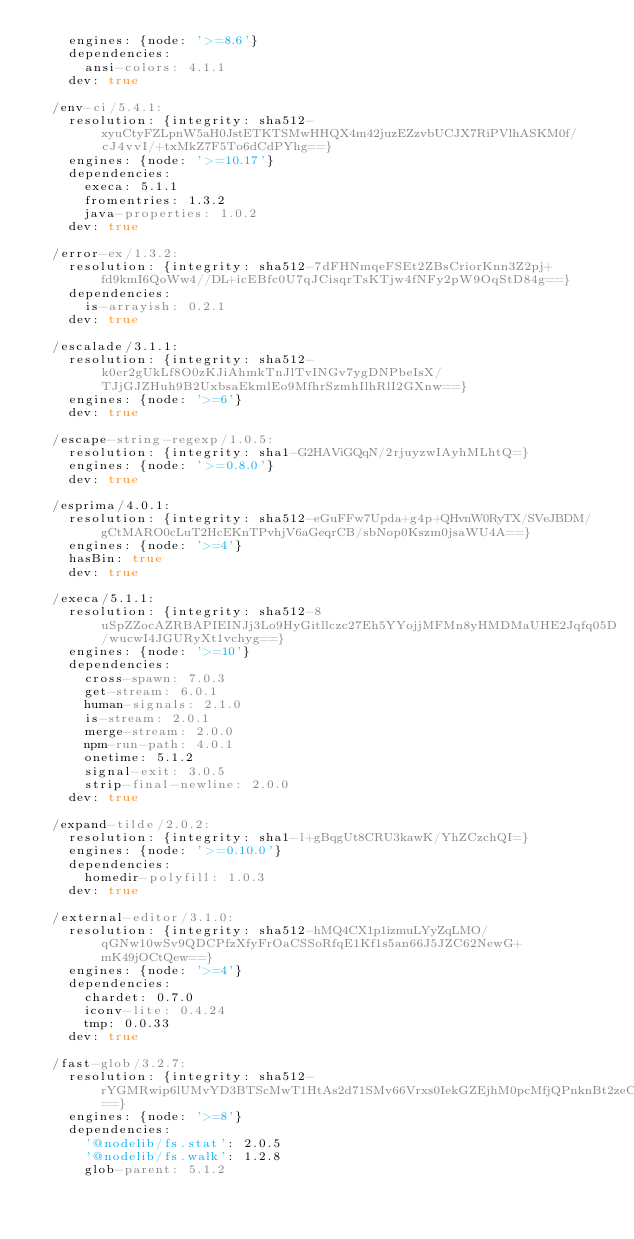Convert code to text. <code><loc_0><loc_0><loc_500><loc_500><_YAML_>    engines: {node: '>=8.6'}
    dependencies:
      ansi-colors: 4.1.1
    dev: true

  /env-ci/5.4.1:
    resolution: {integrity: sha512-xyuCtyFZLpnW5aH0JstETKTSMwHHQX4m42juzEZzvbUCJX7RiPVlhASKM0f/cJ4vvI/+txMkZ7F5To6dCdPYhg==}
    engines: {node: '>=10.17'}
    dependencies:
      execa: 5.1.1
      fromentries: 1.3.2
      java-properties: 1.0.2
    dev: true

  /error-ex/1.3.2:
    resolution: {integrity: sha512-7dFHNmqeFSEt2ZBsCriorKnn3Z2pj+fd9kmI6QoWw4//DL+icEBfc0U7qJCisqrTsKTjw4fNFy2pW9OqStD84g==}
    dependencies:
      is-arrayish: 0.2.1
    dev: true

  /escalade/3.1.1:
    resolution: {integrity: sha512-k0er2gUkLf8O0zKJiAhmkTnJlTvINGv7ygDNPbeIsX/TJjGJZHuh9B2UxbsaEkmlEo9MfhrSzmhIlhRlI2GXnw==}
    engines: {node: '>=6'}
    dev: true

  /escape-string-regexp/1.0.5:
    resolution: {integrity: sha1-G2HAViGQqN/2rjuyzwIAyhMLhtQ=}
    engines: {node: '>=0.8.0'}
    dev: true

  /esprima/4.0.1:
    resolution: {integrity: sha512-eGuFFw7Upda+g4p+QHvnW0RyTX/SVeJBDM/gCtMARO0cLuT2HcEKnTPvhjV6aGeqrCB/sbNop0Kszm0jsaWU4A==}
    engines: {node: '>=4'}
    hasBin: true
    dev: true

  /execa/5.1.1:
    resolution: {integrity: sha512-8uSpZZocAZRBAPIEINJj3Lo9HyGitllczc27Eh5YYojjMFMn8yHMDMaUHE2Jqfq05D/wucwI4JGURyXt1vchyg==}
    engines: {node: '>=10'}
    dependencies:
      cross-spawn: 7.0.3
      get-stream: 6.0.1
      human-signals: 2.1.0
      is-stream: 2.0.1
      merge-stream: 2.0.0
      npm-run-path: 4.0.1
      onetime: 5.1.2
      signal-exit: 3.0.5
      strip-final-newline: 2.0.0
    dev: true

  /expand-tilde/2.0.2:
    resolution: {integrity: sha1-l+gBqgUt8CRU3kawK/YhZCzchQI=}
    engines: {node: '>=0.10.0'}
    dependencies:
      homedir-polyfill: 1.0.3
    dev: true

  /external-editor/3.1.0:
    resolution: {integrity: sha512-hMQ4CX1p1izmuLYyZqLMO/qGNw10wSv9QDCPfzXfyFrOaCSSoRfqE1Kf1s5an66J5JZC62NewG+mK49jOCtQew==}
    engines: {node: '>=4'}
    dependencies:
      chardet: 0.7.0
      iconv-lite: 0.4.24
      tmp: 0.0.33
    dev: true

  /fast-glob/3.2.7:
    resolution: {integrity: sha512-rYGMRwip6lUMvYD3BTScMwT1HtAs2d71SMv66Vrxs0IekGZEjhM0pcMfjQPnknBt2zeCwQMEupiN02ZP4DiT1Q==}
    engines: {node: '>=8'}
    dependencies:
      '@nodelib/fs.stat': 2.0.5
      '@nodelib/fs.walk': 1.2.8
      glob-parent: 5.1.2</code> 